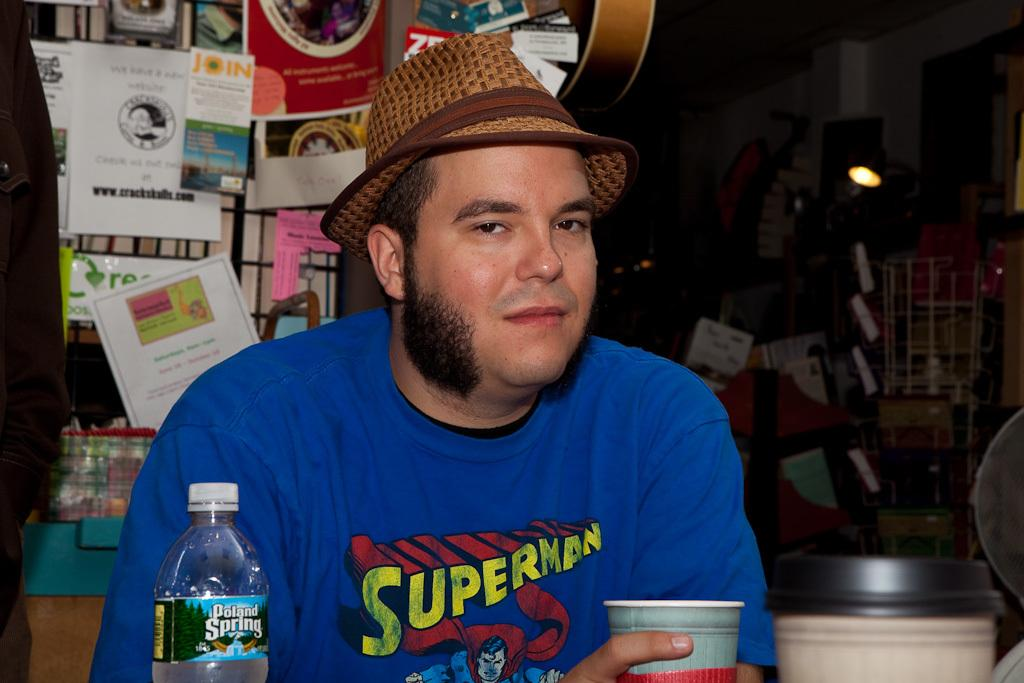Who is present in the image? There is a man in the image. What is the man holding in the image? The man is holding a cup. What other object can be seen in the image? There is a bottle in the image. What accessory is the man wearing? The man is wearing a hat. What can be seen in the background of the image? There are books and a light in the background of the image. What type of pet is sitting next to the man in the image? There is no pet present in the image; only the man, cup, bottle, hat, books, and light can be seen. 